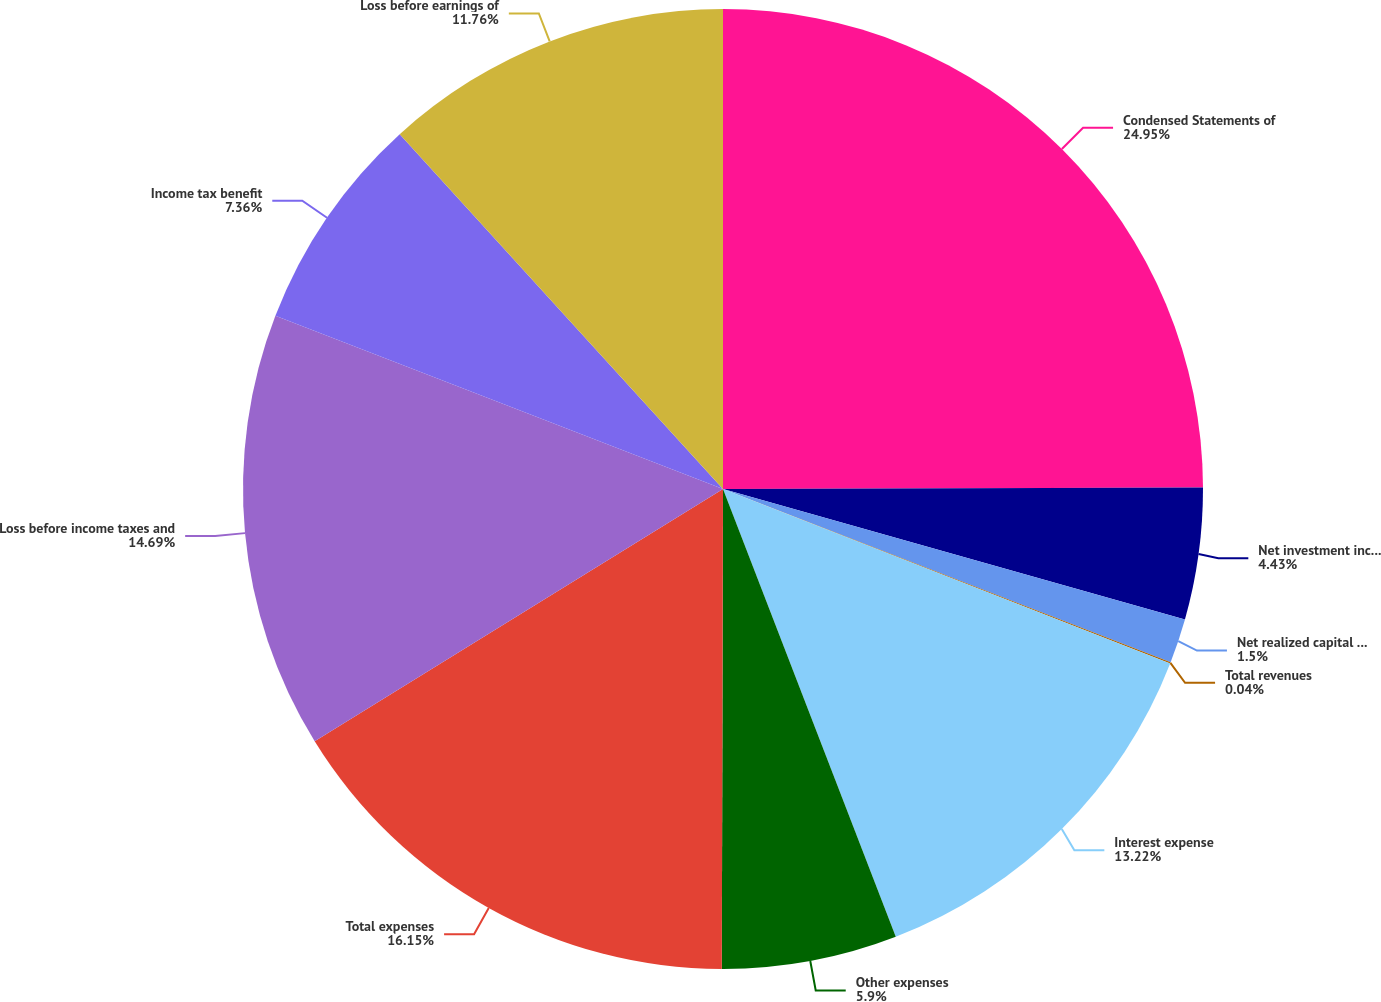<chart> <loc_0><loc_0><loc_500><loc_500><pie_chart><fcel>Condensed Statements of<fcel>Net investment income<fcel>Net realized capital losses<fcel>Total revenues<fcel>Interest expense<fcel>Other expenses<fcel>Total expenses<fcel>Loss before income taxes and<fcel>Income tax benefit<fcel>Loss before earnings of<nl><fcel>24.95%<fcel>4.43%<fcel>1.5%<fcel>0.04%<fcel>13.22%<fcel>5.9%<fcel>16.15%<fcel>14.69%<fcel>7.36%<fcel>11.76%<nl></chart> 